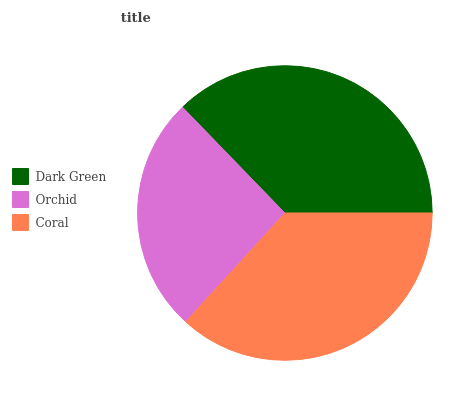Is Orchid the minimum?
Answer yes or no. Yes. Is Dark Green the maximum?
Answer yes or no. Yes. Is Coral the minimum?
Answer yes or no. No. Is Coral the maximum?
Answer yes or no. No. Is Coral greater than Orchid?
Answer yes or no. Yes. Is Orchid less than Coral?
Answer yes or no. Yes. Is Orchid greater than Coral?
Answer yes or no. No. Is Coral less than Orchid?
Answer yes or no. No. Is Coral the high median?
Answer yes or no. Yes. Is Coral the low median?
Answer yes or no. Yes. Is Orchid the high median?
Answer yes or no. No. Is Dark Green the low median?
Answer yes or no. No. 